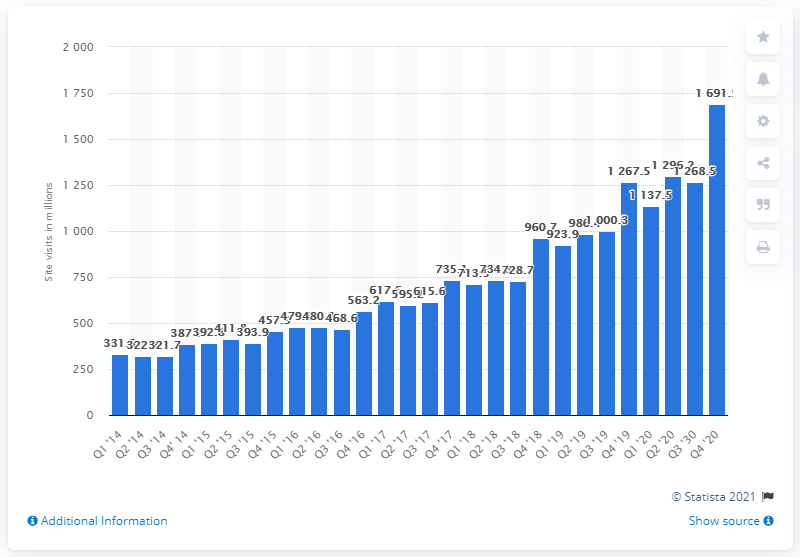Identify some key points in this picture. During the last quarter of 2020, the average number of visitors to Zalando's website was 331.8. During the most recent quarter, a total of 1,691.5 visitors accessed Zalando's website. 